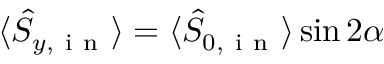Convert formula to latex. <formula><loc_0><loc_0><loc_500><loc_500>\langle \hat { S } _ { y , i n } \rangle = \langle \hat { S } _ { 0 , i n } \rangle \sin { 2 \alpha }</formula> 